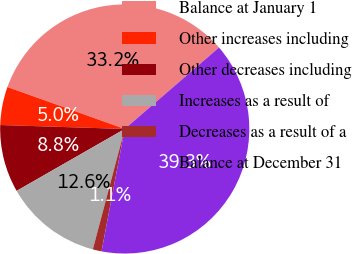Convert chart to OTSL. <chart><loc_0><loc_0><loc_500><loc_500><pie_chart><fcel>Balance at January 1<fcel>Other increases including<fcel>Other decreases including<fcel>Increases as a result of<fcel>Decreases as a result of a<fcel>Balance at December 31<nl><fcel>33.19%<fcel>4.96%<fcel>8.78%<fcel>12.6%<fcel>1.14%<fcel>39.32%<nl></chart> 